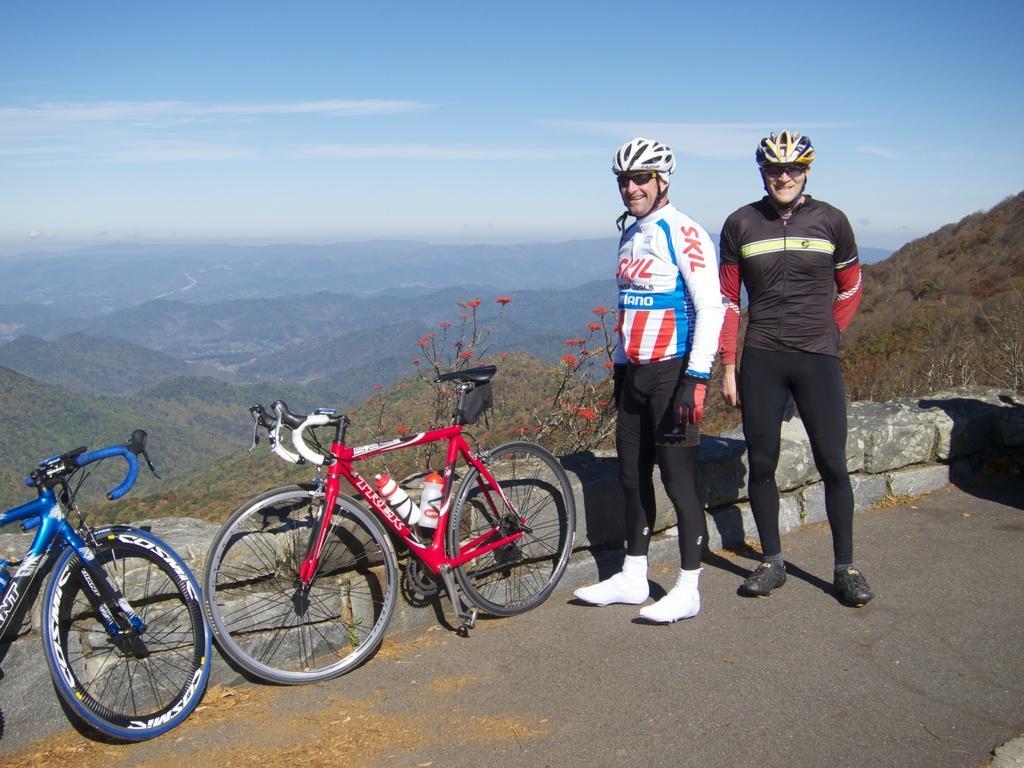How would you summarize this image in a sentence or two? In this image we can see two men wearing the helmets standing on the ground. We can also see two bicycles placed beside a wall. On the backside we can see a group of trees, the hills and the sky which looks cloudy. 